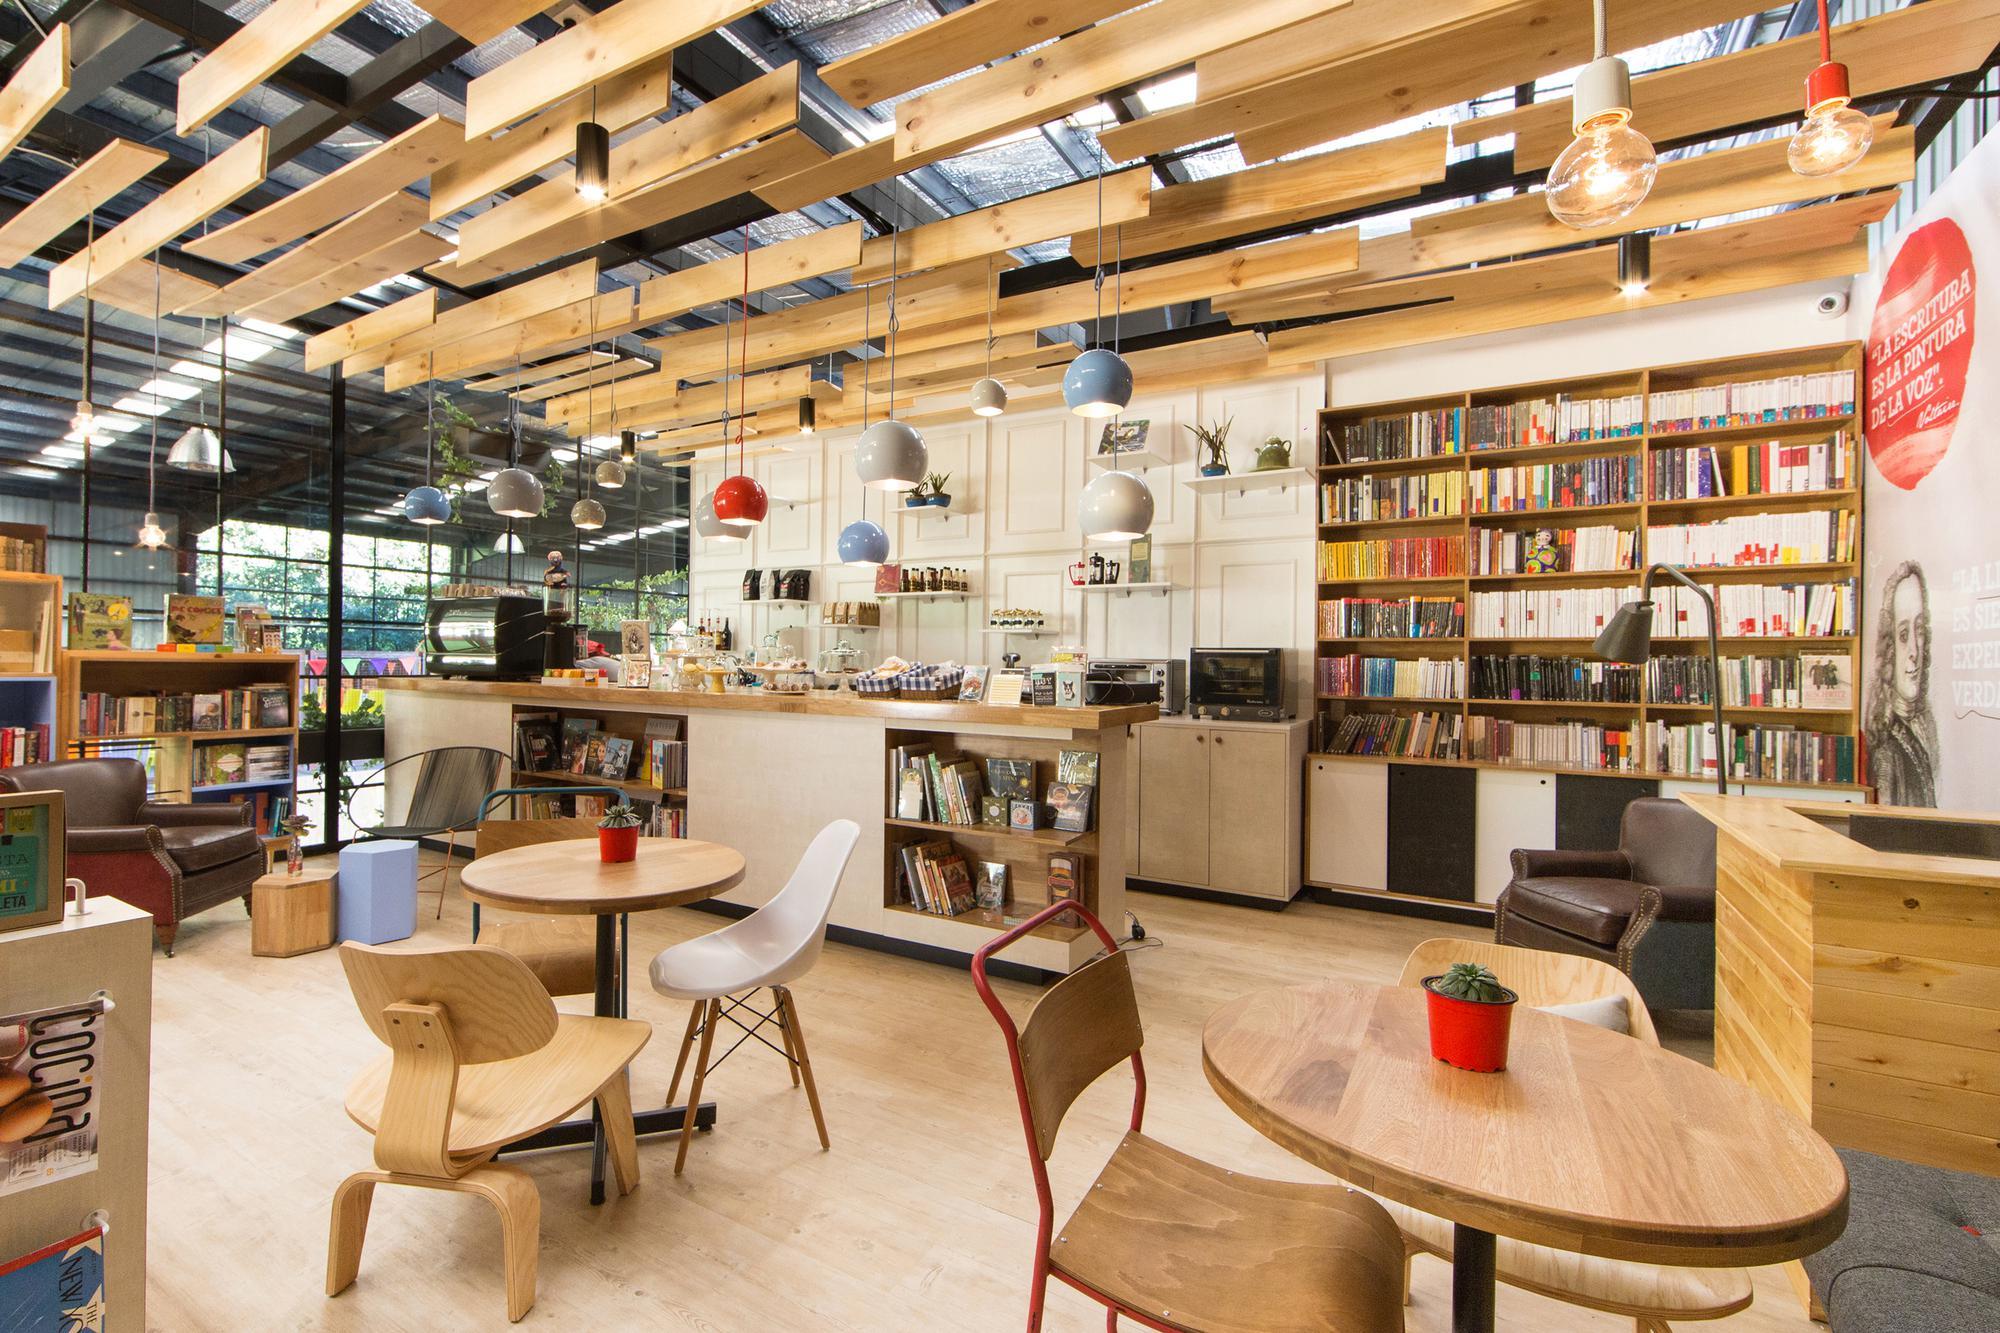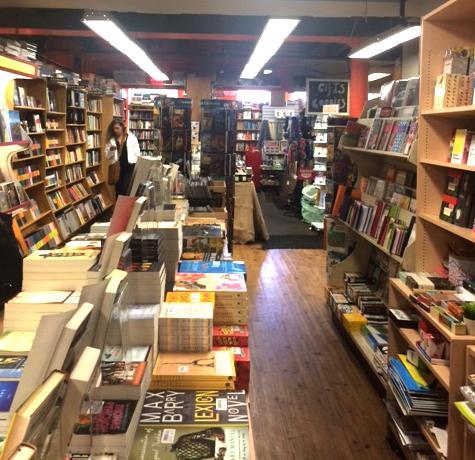The first image is the image on the left, the second image is the image on the right. Examine the images to the left and right. Is the description "There are no more than 4 people in the image on the right." accurate? Answer yes or no. Yes. 